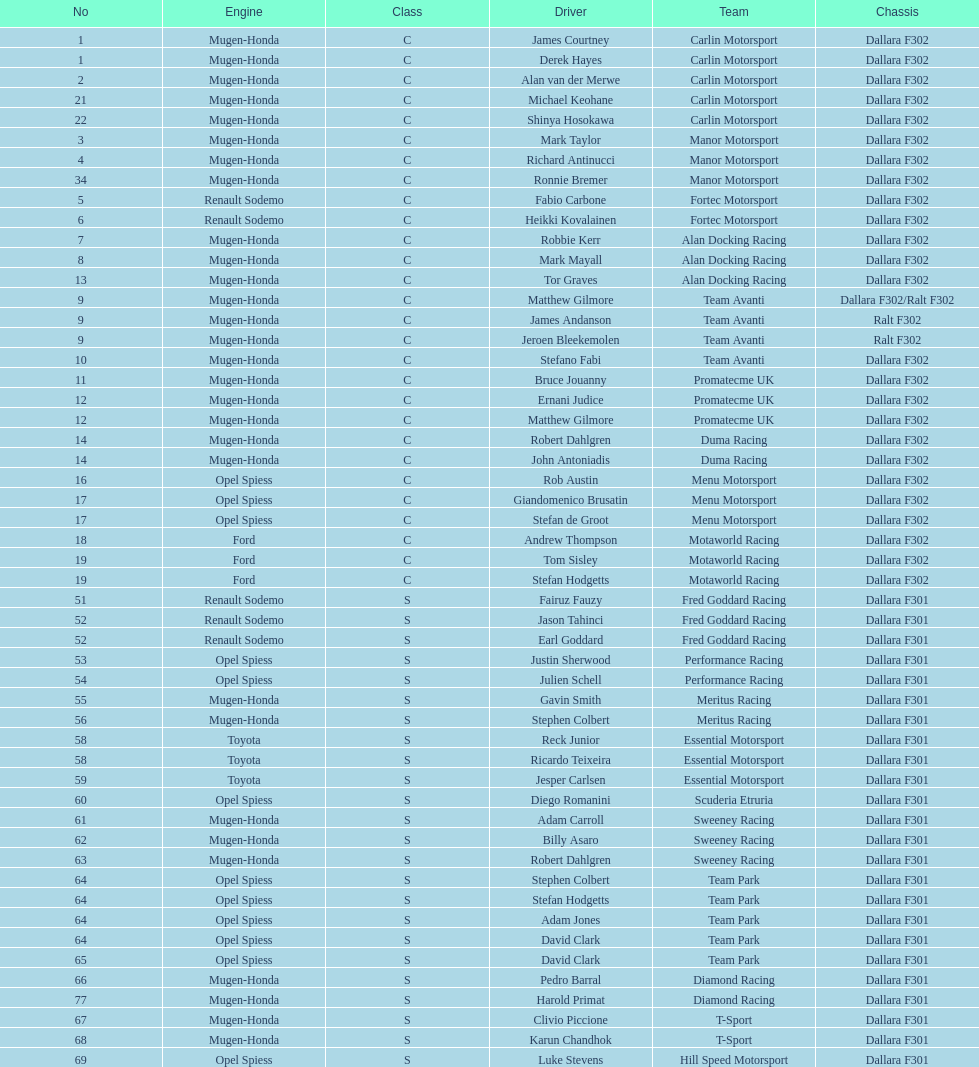How many class s (scholarship) teams are on the chart? 19. 